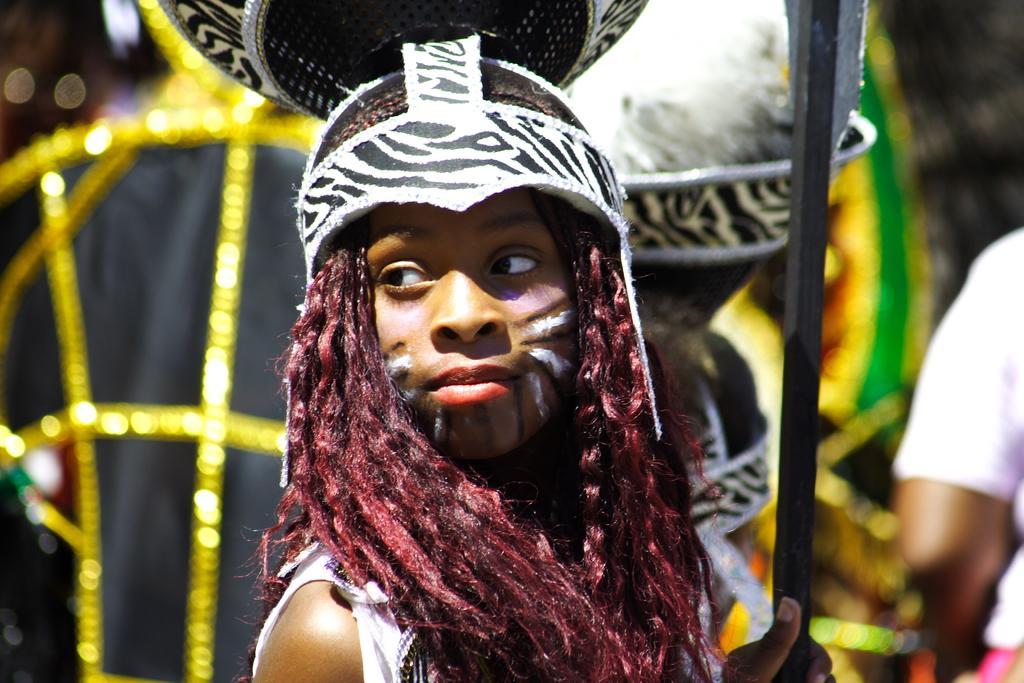Can you describe this image briefly? In this image we can see a person with a costume. And the person is holding a rod. In the background it is blurry and we can see few people. 